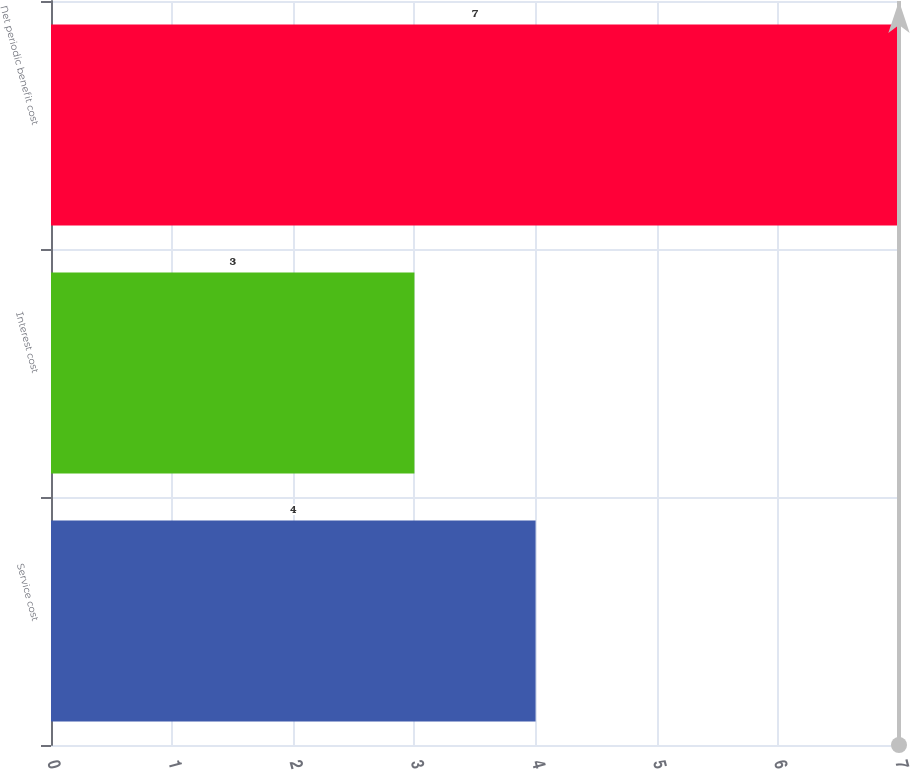Convert chart to OTSL. <chart><loc_0><loc_0><loc_500><loc_500><bar_chart><fcel>Service cost<fcel>Interest cost<fcel>Net periodic benefit cost<nl><fcel>4<fcel>3<fcel>7<nl></chart> 